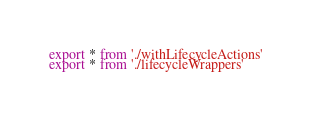<code> <loc_0><loc_0><loc_500><loc_500><_JavaScript_>export * from './withLifecycleActions'
export * from './lifecycleWrappers'
</code> 